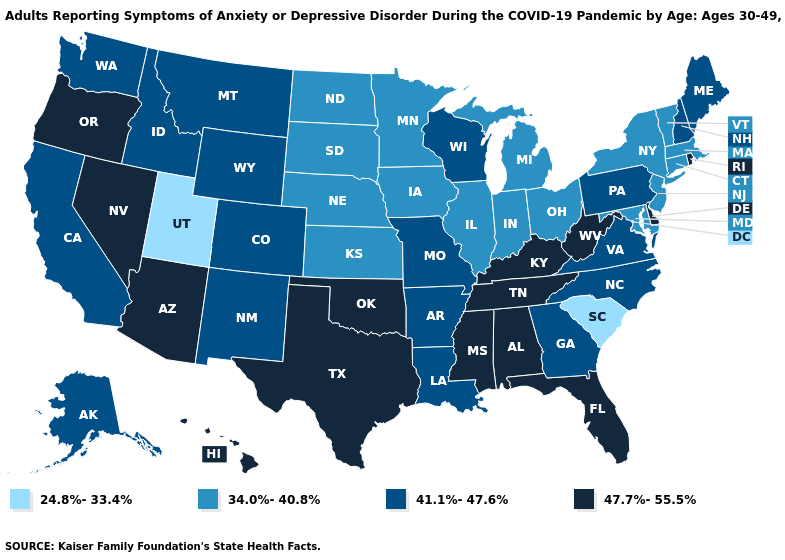What is the value of Iowa?
Be succinct. 34.0%-40.8%. What is the value of Texas?
Quick response, please. 47.7%-55.5%. What is the lowest value in states that border Nebraska?
Write a very short answer. 34.0%-40.8%. What is the highest value in the USA?
Write a very short answer. 47.7%-55.5%. What is the value of New Jersey?
Concise answer only. 34.0%-40.8%. What is the value of Connecticut?
Write a very short answer. 34.0%-40.8%. What is the highest value in the MidWest ?
Give a very brief answer. 41.1%-47.6%. Does Hawaii have a higher value than Oregon?
Give a very brief answer. No. Which states have the lowest value in the USA?
Concise answer only. South Carolina, Utah. What is the highest value in states that border South Carolina?
Quick response, please. 41.1%-47.6%. Name the states that have a value in the range 41.1%-47.6%?
Concise answer only. Alaska, Arkansas, California, Colorado, Georgia, Idaho, Louisiana, Maine, Missouri, Montana, New Hampshire, New Mexico, North Carolina, Pennsylvania, Virginia, Washington, Wisconsin, Wyoming. Name the states that have a value in the range 24.8%-33.4%?
Write a very short answer. South Carolina, Utah. What is the value of Arizona?
Give a very brief answer. 47.7%-55.5%. Does Delaware have the highest value in the USA?
Answer briefly. Yes. Which states hav the highest value in the South?
Keep it brief. Alabama, Delaware, Florida, Kentucky, Mississippi, Oklahoma, Tennessee, Texas, West Virginia. 